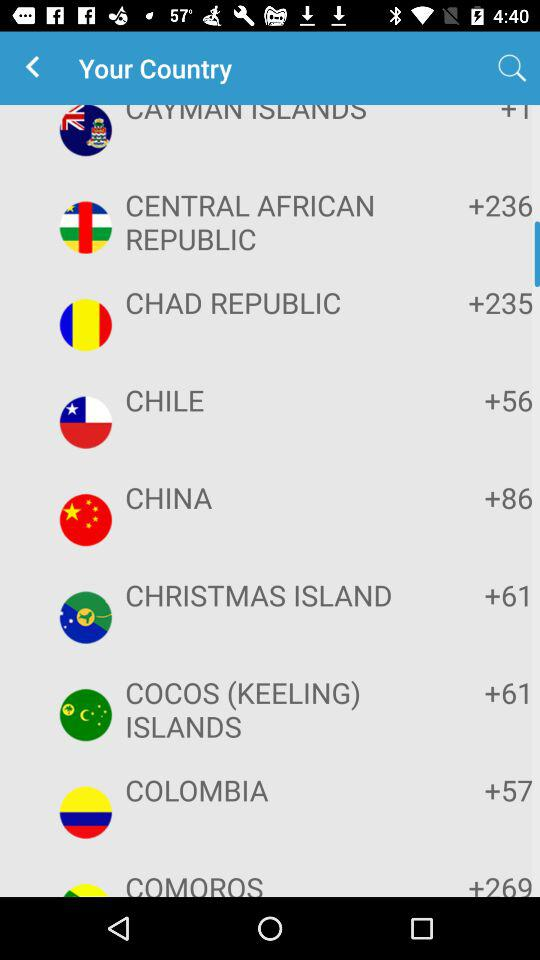What is the country code of Colombia? The country code of Colombia is +57. 